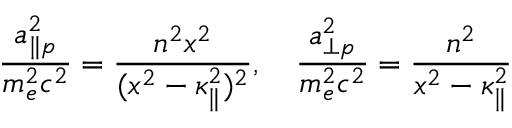<formula> <loc_0><loc_0><loc_500><loc_500>\frac { a _ { \| p } ^ { 2 } } { m _ { e } ^ { 2 } c ^ { 2 } } = \frac { n ^ { 2 } x ^ { 2 } } { ( x ^ { 2 } - \kappa _ { \| } ^ { 2 } ) ^ { 2 } } , \quad \frac { a _ { \perp p } ^ { 2 } } { m _ { e } ^ { 2 } c ^ { 2 } } = \frac { n ^ { 2 } } { x ^ { 2 } - \kappa _ { \| } ^ { 2 } }</formula> 